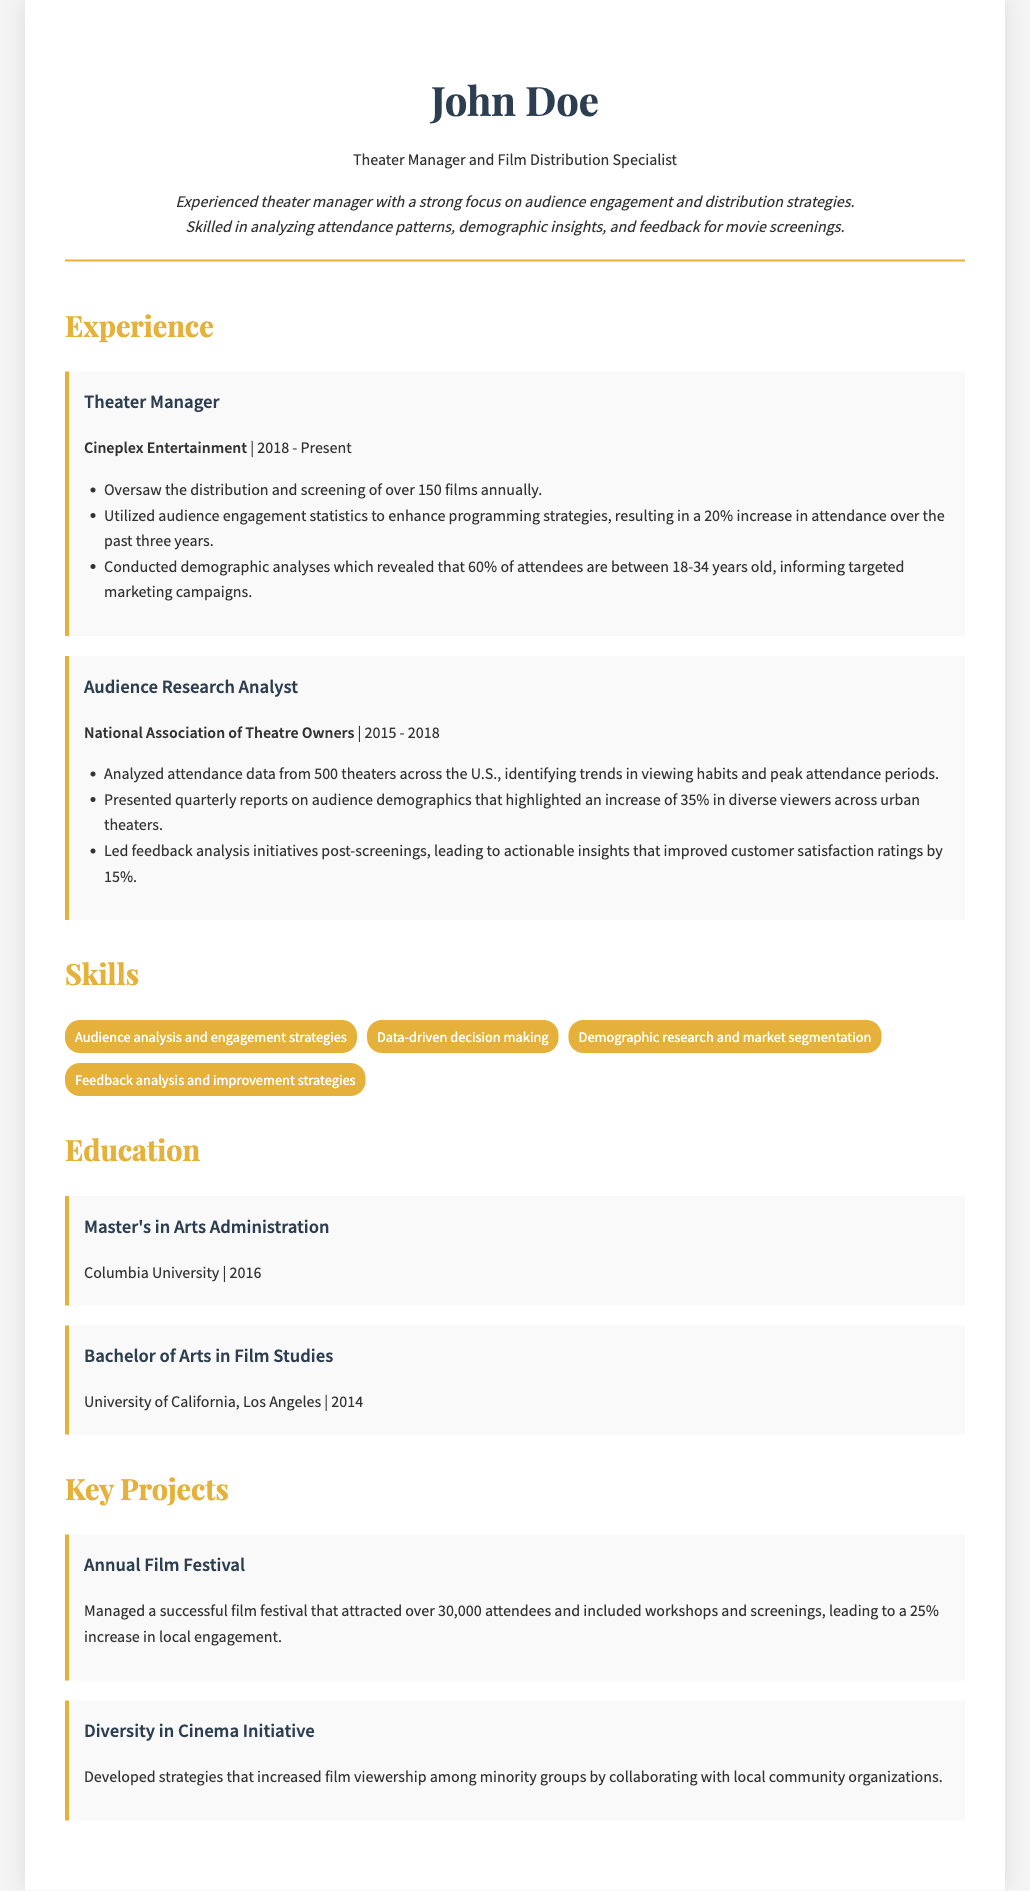What year did John Doe start working at Cineplex Entertainment? The document states John Doe has been a Theater Manager at Cineplex Entertainment since 2018.
Answer: 2018 What percentage increase in attendance has been achieved over the past three years? The document mentions a 20% increase in attendance due to enhanced programming strategies.
Answer: 20% What is the primary demographic that attends the screenings? The document specifies that 60% of attendees are between 18-34 years old.
Answer: 18-34 years old How many theaters' attendance data was analyzed by John Doe in his previous role? The document indicates he analyzed attendance data from 500 theaters across the U.S.
Answer: 500 What was the increase in diverse viewers highlighted in the quarterly reports? The document states there was a 35% increase in diverse viewers across urban theaters.
Answer: 35% What was the improvement in customer satisfaction ratings due to feedback analysis? The document notes that customer satisfaction ratings improved by 15%.
Answer: 15% What degree did John Doe attain from Columbia University? The document lists a Master's in Arts Administration as the degree earned from Columbia University.
Answer: Master's in Arts Administration What event did John Doe manage that attracted over 30,000 attendees? The document refers to an annual film festival that he managed with this attendance.
Answer: Annual Film Festival What initiative did John Doe work on to increase film viewership among minority groups? The document mentions the Diversity in Cinema Initiative as the project he developed strategies for.
Answer: Diversity in Cinema Initiative 